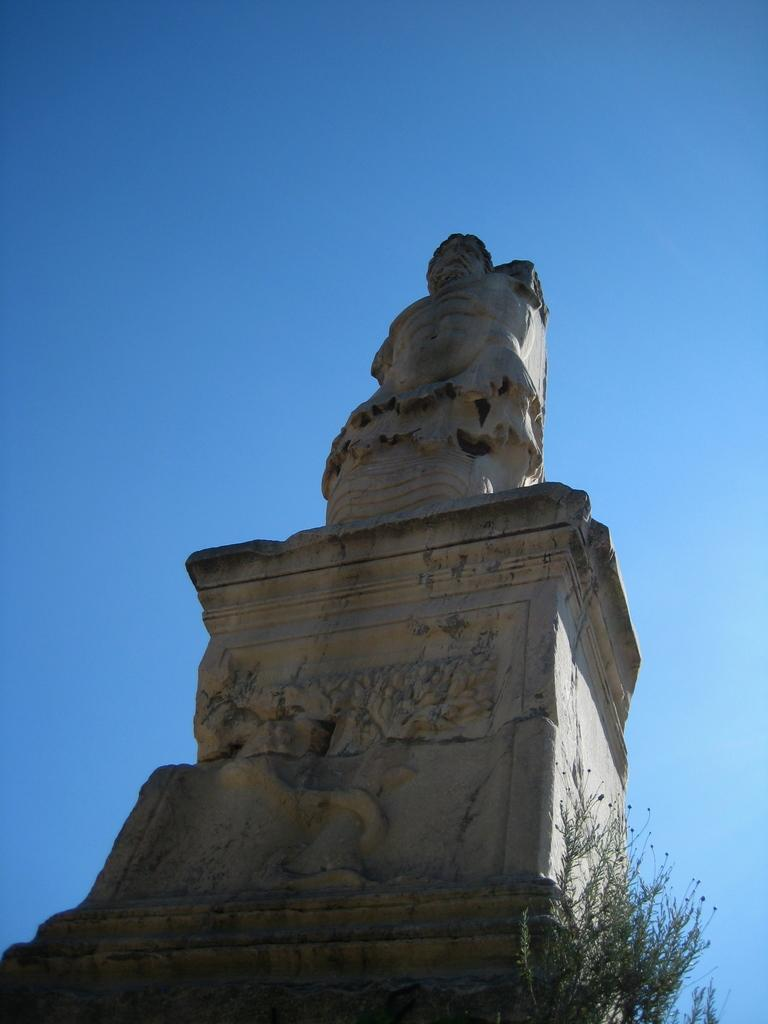What is the main subject in the image? There is a statue in the image. What can be seen on the right side of the statue? There are plants on the right side of the statue. What is visible behind the statue? The sky is visible behind the statue. How many cows are grazing in front of the statue in the image? There are no cows present in the image; the focus is on the statue, plants, and sky. 